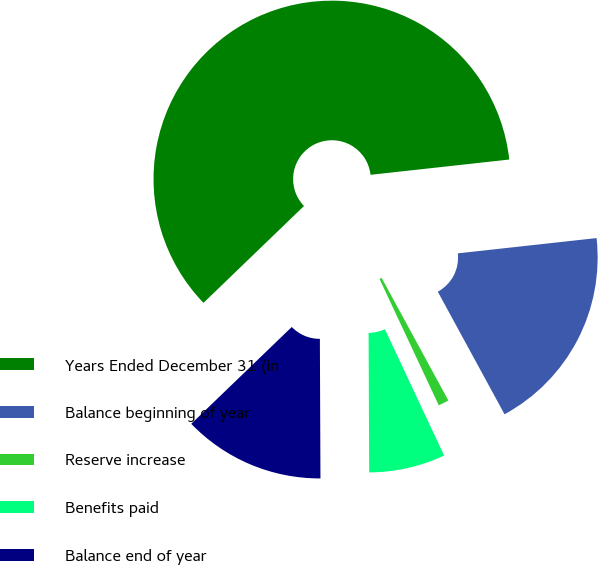<chart> <loc_0><loc_0><loc_500><loc_500><pie_chart><fcel>Years Ended December 31 (in<fcel>Balance beginning of year<fcel>Reserve increase<fcel>Benefits paid<fcel>Balance end of year<nl><fcel>60.46%<fcel>18.81%<fcel>0.96%<fcel>6.91%<fcel>12.86%<nl></chart> 